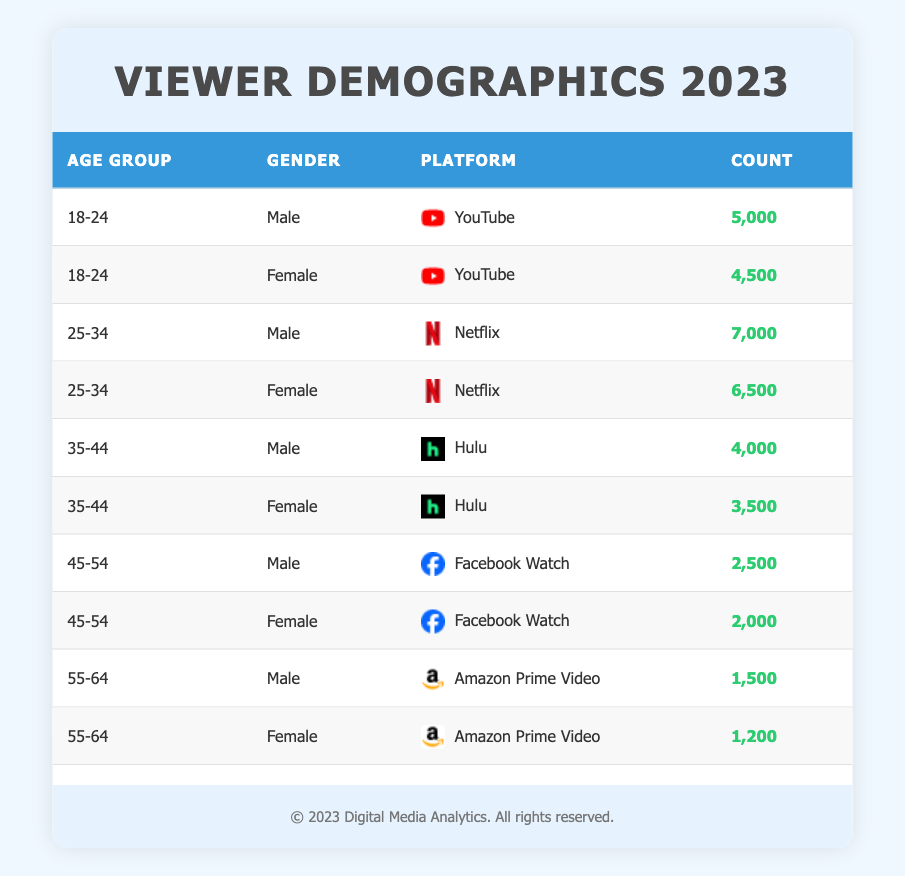What is the total count of viewers aged 25-34 on Netflix? To find the total count of viewers aged 25-34 on Netflix, we look at the specific rows representing that age group. For males, the count is 7,000, and for females, it is 6,500. Summing these gives us 7,000 + 6,500 = 13,500.
Answer: 13,500 Which platform has the highest number of male viewers aged 18-24? We check the count for male viewers in the age group 18-24 across different platforms. The only platform for this age group is YouTube, with a count of 5,000, as there are no other entries for male viewers in this age group.
Answer: YouTube Is the count of female viewers aged 35-44 on Hulu greater than the count of male viewers in the same age group? The count of female viewers aged 35-44 on Hulu is 3,500, while the count of male viewers in the same age group is 4,000. Since 3,500 is not greater than 4,000, the answer is false.
Answer: No What is the difference in viewer counts between males and females aged 45-54 on Facebook Watch? For males aged 45-54, the count is 2,500, and for females, it is 2,000. The difference can be calculated as 2,500 - 2,000 = 500.
Answer: 500 What is the average number of viewers for females across all age groups on Amazon Prime Video? There is one entry for female viewers aged 55-64 on Amazon Prime Video with a count of 1,200. Thus, since there are no other female viewers on this platform, the average is simply 1,200.
Answer: 1,200 Are there more male viewers aged 55-64 on Amazon Prime Video than female viewers aged 55-64 on the same platform? The count for males aged 55-64 is 1,500, while the count for females is 1,200. Since 1,500 is greater than 1,200, the answer is true.
Answer: Yes What is the total count of viewers across all age groups on Hulu? We sum the counts for both male and female viewers aged 35-44 on Hulu: 4,000 (males) + 3,500 (females) = 7,500. There are no entries for other age groups on Hulu, so this is the total.
Answer: 7,500 Which age group has the lowest count of viewers among females? We review the counts for females in each age group: 4,500 (18-24), 6,500 (25-34), 3,500 (35-44), 2,000 (45-54), and 1,200 (55-64). The lowest count is 1,200 for the age group 55-64.
Answer: 55-64 